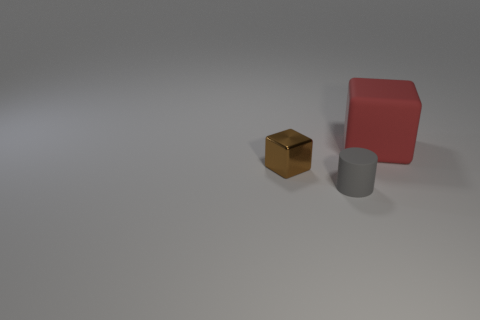Add 3 big yellow cubes. How many objects exist? 6 Subtract all cylinders. How many objects are left? 2 Add 1 big gray rubber balls. How many big gray rubber balls exist? 1 Subtract 0 gray blocks. How many objects are left? 3 Subtract all small rubber cylinders. Subtract all small metallic objects. How many objects are left? 1 Add 3 red things. How many red things are left? 4 